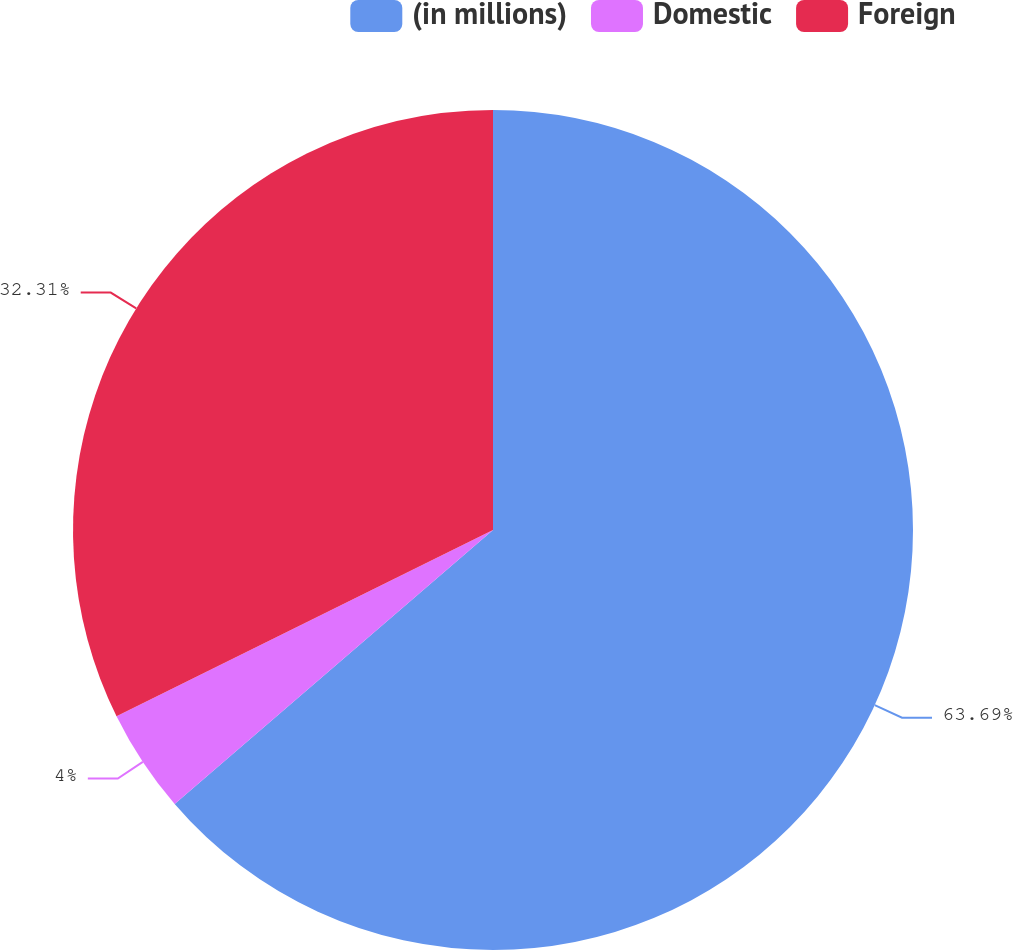Convert chart to OTSL. <chart><loc_0><loc_0><loc_500><loc_500><pie_chart><fcel>(in millions)<fcel>Domestic<fcel>Foreign<nl><fcel>63.69%<fcel>4.0%<fcel>32.31%<nl></chart> 